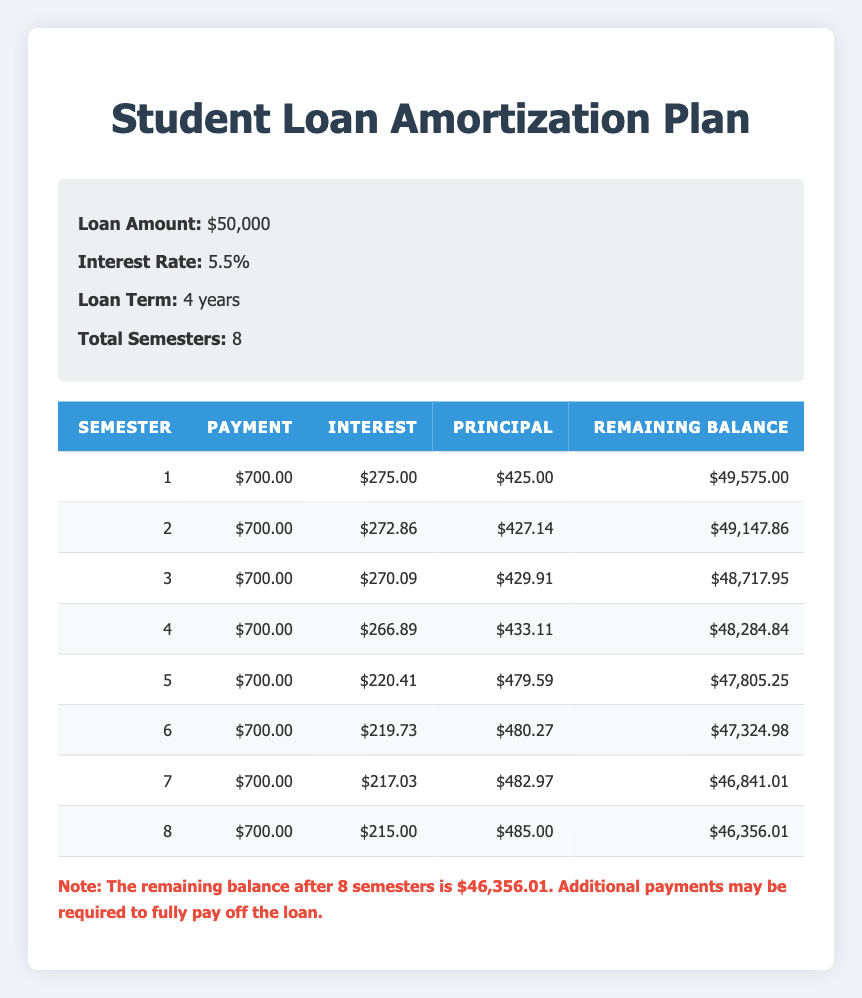What is the total payment made after the first two semesters? The payment for each semester is $700. After two semesters, the total payment is calculated as 700 + 700 = 1400.
Answer: 1400 What is the interest payment for the fifth semester? Referring to the table, the interest payment for the fifth semester is $220.41.
Answer: 220.41 Is the principal payment for semester 3 greater than 430? Checking the table, the principal payment for semester 3 is $429.91, which is less than 430.
Answer: No What is the remaining balance after semester 4? The remaining balance after semester 4, as shown in the table, is $48,284.84.
Answer: 48284.84 What is the average principal payment across all semesters? The principal payments are: 425, 427.14, 429.91, 433.11, 479.59, 480.27, 482.97, and 485. Summing these gives: 425 + 427.14 + 429.91 + 433.11 + 479.59 + 480.27 + 482.97 + 485 = 3,440. The average is then calculated: 3440 / 8 = 430.
Answer: 430 How much was the total interest paid by the end of semester 8? The interest payments for all semesters are: 275, 272.86, 270.09, 266.89, 220.41, 219.73, 217.03, and 215. The total interest paid is: 275 + 272.86 + 270.09 + 266.89 + 220.41 + 219.73 + 217.03 + 215 = 1,197.01.
Answer: 1197.01 Does the principal payment increase every semester? Examining the table, the principal payments are: 425, 427.14, 429.91, 433.11, 479.59, 480.27, 482.97, and 485. While the payments generally increase, the fourth semester shows an increase, but then the fifth semester shows a much larger increase compared to the previous ones.
Answer: Yes What is the difference in interest payments between the first and last semester? The first semester's interest payment is $275.00 and the last semester's interest payment is $215.00. The difference is calculated as 275 - 215 = 60.
Answer: 60 